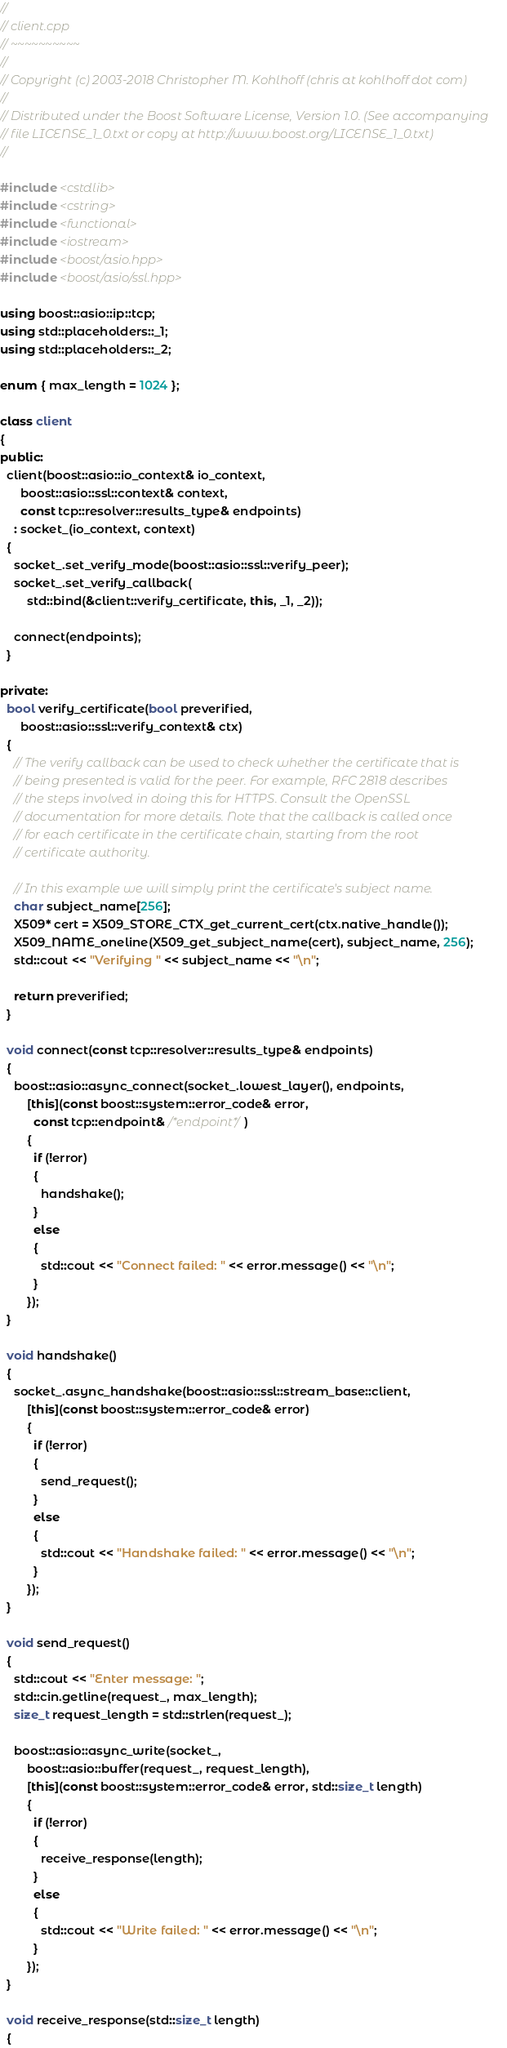Convert code to text. <code><loc_0><loc_0><loc_500><loc_500><_C++_>//
// client.cpp
// ~~~~~~~~~~
//
// Copyright (c) 2003-2018 Christopher M. Kohlhoff (chris at kohlhoff dot com)
//
// Distributed under the Boost Software License, Version 1.0. (See accompanying
// file LICENSE_1_0.txt or copy at http://www.boost.org/LICENSE_1_0.txt)
//

#include <cstdlib>
#include <cstring>
#include <functional>
#include <iostream>
#include <boost/asio.hpp>
#include <boost/asio/ssl.hpp>

using boost::asio::ip::tcp;
using std::placeholders::_1;
using std::placeholders::_2;

enum { max_length = 1024 };

class client
{
public:
  client(boost::asio::io_context& io_context,
      boost::asio::ssl::context& context,
      const tcp::resolver::results_type& endpoints)
    : socket_(io_context, context)
  {
    socket_.set_verify_mode(boost::asio::ssl::verify_peer);
    socket_.set_verify_callback(
        std::bind(&client::verify_certificate, this, _1, _2));

    connect(endpoints);
  }

private:
  bool verify_certificate(bool preverified,
      boost::asio::ssl::verify_context& ctx)
  {
    // The verify callback can be used to check whether the certificate that is
    // being presented is valid for the peer. For example, RFC 2818 describes
    // the steps involved in doing this for HTTPS. Consult the OpenSSL
    // documentation for more details. Note that the callback is called once
    // for each certificate in the certificate chain, starting from the root
    // certificate authority.

    // In this example we will simply print the certificate's subject name.
    char subject_name[256];
    X509* cert = X509_STORE_CTX_get_current_cert(ctx.native_handle());
    X509_NAME_oneline(X509_get_subject_name(cert), subject_name, 256);
    std::cout << "Verifying " << subject_name << "\n";

    return preverified;
  }

  void connect(const tcp::resolver::results_type& endpoints)
  {
    boost::asio::async_connect(socket_.lowest_layer(), endpoints,
        [this](const boost::system::error_code& error,
          const tcp::endpoint& /*endpoint*/)
        {
          if (!error)
          {
            handshake();
          }
          else
          {
            std::cout << "Connect failed: " << error.message() << "\n";
          }
        });
  }

  void handshake()
  {
    socket_.async_handshake(boost::asio::ssl::stream_base::client,
        [this](const boost::system::error_code& error)
        {
          if (!error)
          {
            send_request();
          }
          else
          {
            std::cout << "Handshake failed: " << error.message() << "\n";
          }
        });
  }

  void send_request()
  {
    std::cout << "Enter message: ";
    std::cin.getline(request_, max_length);
    size_t request_length = std::strlen(request_);

    boost::asio::async_write(socket_,
        boost::asio::buffer(request_, request_length),
        [this](const boost::system::error_code& error, std::size_t length)
        {
          if (!error)
          {
            receive_response(length);
          }
          else
          {
            std::cout << "Write failed: " << error.message() << "\n";
          }
        });
  }

  void receive_response(std::size_t length)
  {</code> 